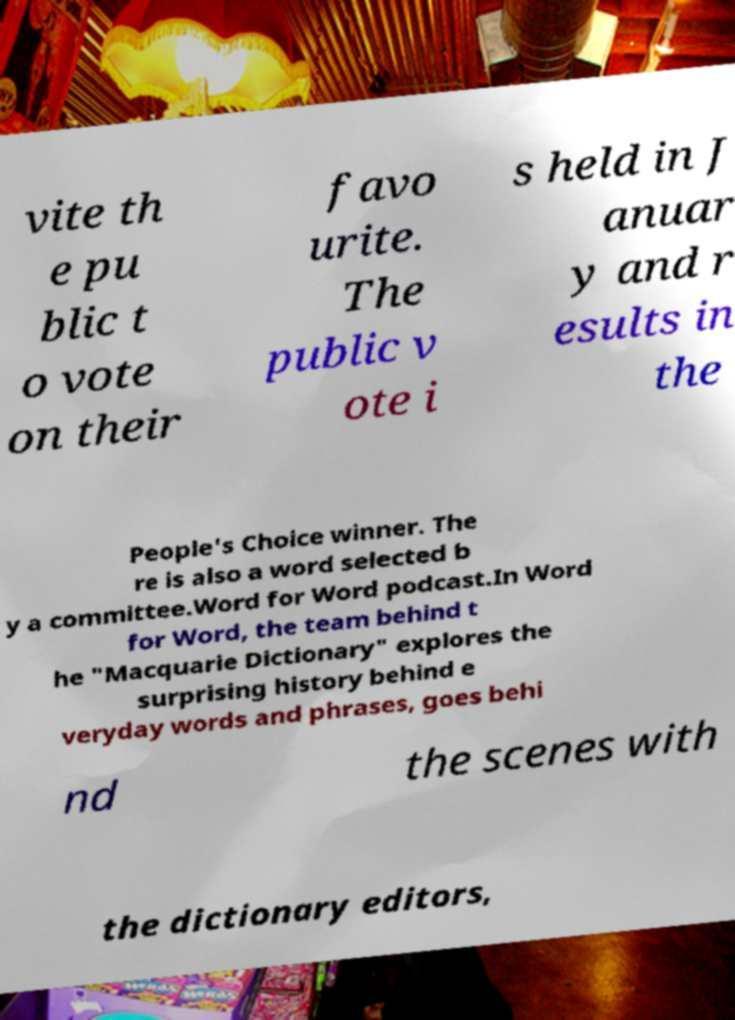Could you assist in decoding the text presented in this image and type it out clearly? vite th e pu blic t o vote on their favo urite. The public v ote i s held in J anuar y and r esults in the People's Choice winner. The re is also a word selected b y a committee.Word for Word podcast.In Word for Word, the team behind t he "Macquarie Dictionary" explores the surprising history behind e veryday words and phrases, goes behi nd the scenes with the dictionary editors, 